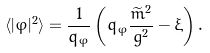Convert formula to latex. <formula><loc_0><loc_0><loc_500><loc_500>\langle | \varphi | ^ { 2 } \rangle = \frac { 1 } { q _ { \varphi } } \left ( q _ { \varphi } \frac { \widetilde { m } ^ { 2 } } { g ^ { 2 } } - \xi \right ) .</formula> 